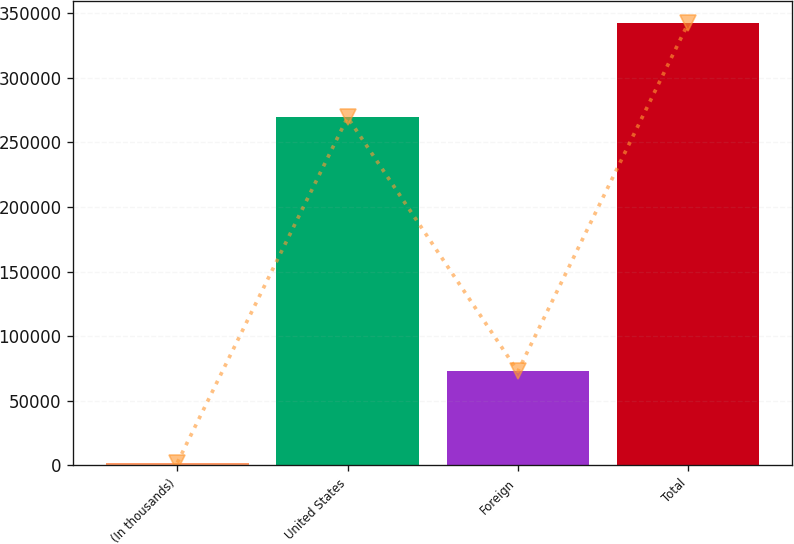<chart> <loc_0><loc_0><loc_500><loc_500><bar_chart><fcel>(In thousands)<fcel>United States<fcel>Foreign<fcel>Total<nl><fcel>2014<fcel>269503<fcel>72707<fcel>342210<nl></chart> 